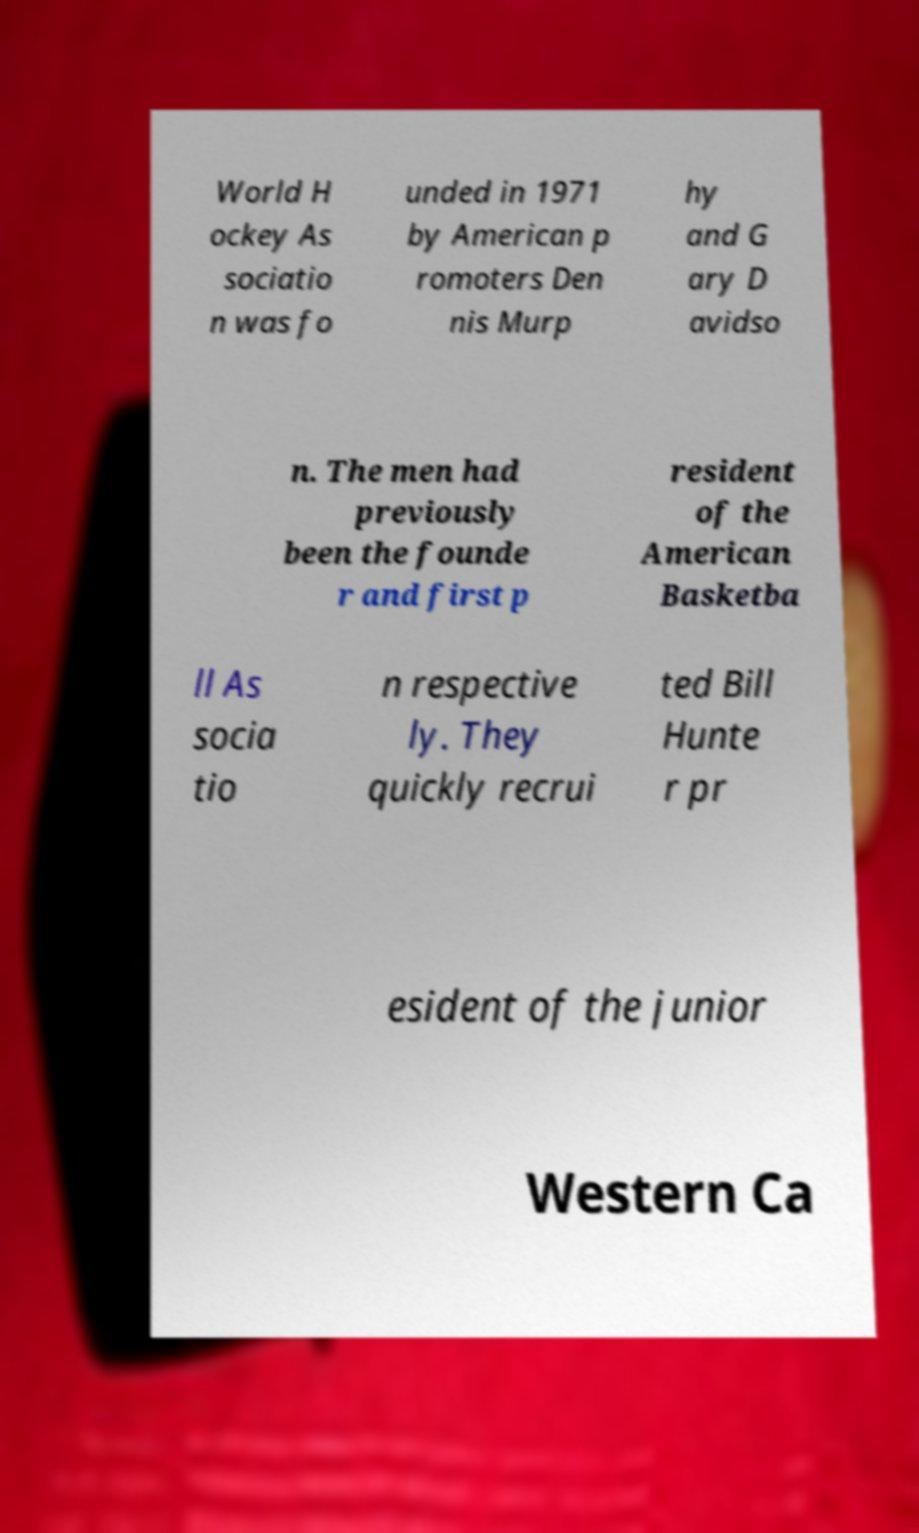Can you accurately transcribe the text from the provided image for me? World H ockey As sociatio n was fo unded in 1971 by American p romoters Den nis Murp hy and G ary D avidso n. The men had previously been the founde r and first p resident of the American Basketba ll As socia tio n respective ly. They quickly recrui ted Bill Hunte r pr esident of the junior Western Ca 